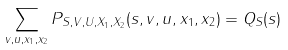Convert formula to latex. <formula><loc_0><loc_0><loc_500><loc_500>\sum _ { v , u , x _ { 1 } , x _ { 2 } } P _ { S , V , U , X _ { 1 } , X _ { 2 } } ( s , v , u , x _ { 1 } , x _ { 2 } ) = Q _ { S } ( s )</formula> 